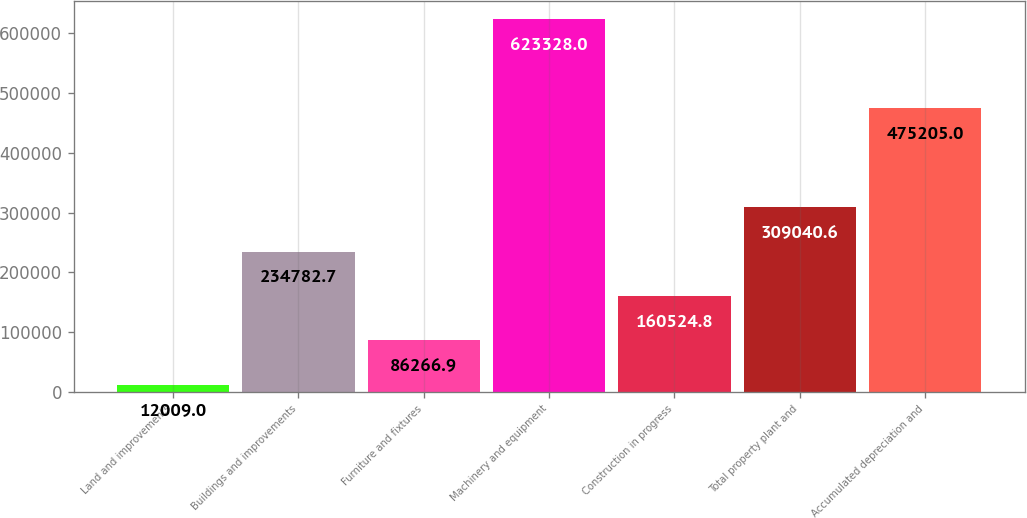<chart> <loc_0><loc_0><loc_500><loc_500><bar_chart><fcel>Land and improvements<fcel>Buildings and improvements<fcel>Furniture and fixtures<fcel>Machinery and equipment<fcel>Construction in progress<fcel>Total property plant and<fcel>Accumulated depreciation and<nl><fcel>12009<fcel>234783<fcel>86266.9<fcel>623328<fcel>160525<fcel>309041<fcel>475205<nl></chart> 